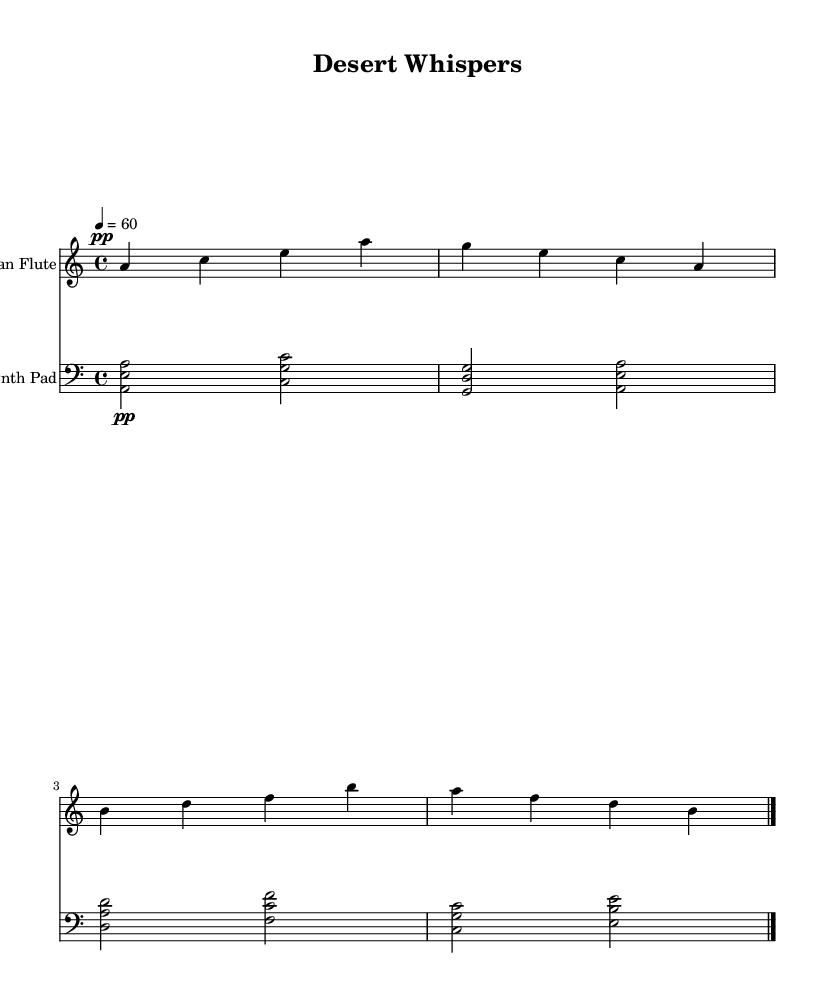What is the key signature of this music? The key signature is A minor, which is indicated by one sharp (G#) but can be recognized by its relative major key, C major, having no sharps or flats.
Answer: A minor What is the time signature of the piece? The time signature is 4/4, which is shown at the beginning of the score and indicates that there are four beats in each measure.
Answer: 4/4 What is the tempo marking of the music? The tempo marking is 60 beats per minute, indicated by the number 4 = 60, specifying how fast the music should be played.
Answer: 60 Which instrument plays the main melodic line? The instrument that plays the main melodic line is the Native American flute, as indicated in the score header.
Answer: Native American Flute How many measures are in the flute part? The flute part contains 4 measures, which can be counted based on the vertical bar lines that separate each measure in the sheet music.
Answer: 4 What type of music fusion is represented here? The fusion represents ambient music blending traditional Native American flute sounds with ambient synths, characterized by its soothing and atmospheric textures.
Answer: Ambient Fusion What dynamic marking is used for the flute music? The dynamic marking is pianissimo, indicated by the "pp" symbol, which instructs the performer to play very softly.
Answer: Pianissimo 